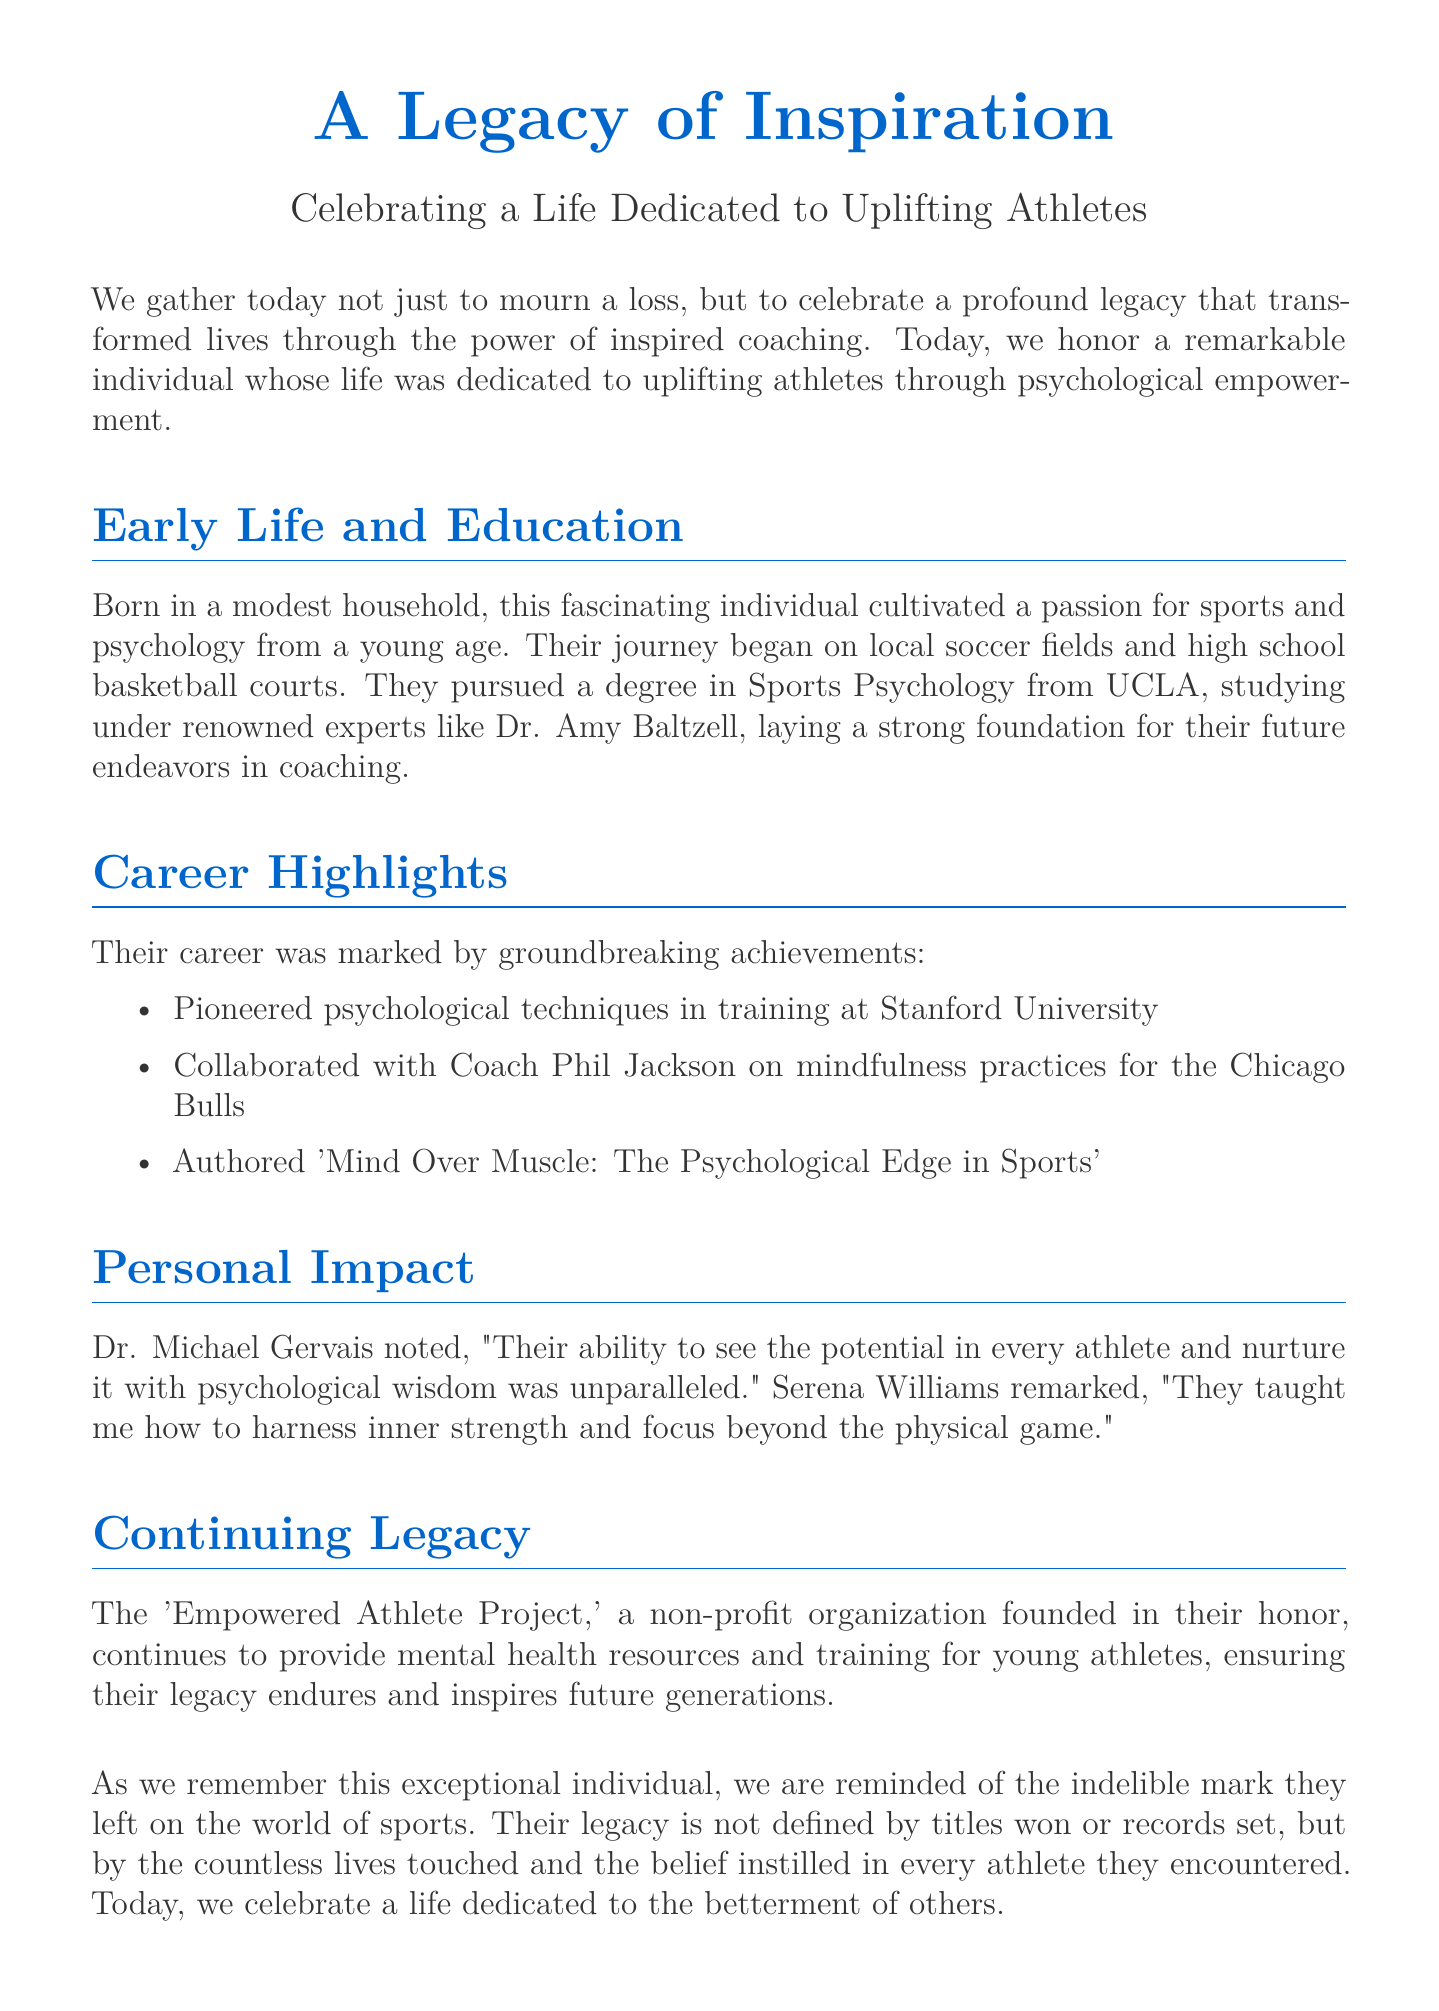What degree did they pursue? The document states they pursued a degree in Sports Psychology from UCLA, which is mentioned under the Early Life and Education section.
Answer: Sports Psychology Which organization did they collaborate with? The document indicates that they collaborated with Coach Phil Jackson, as noted in the Career Highlights section.
Answer: Coach Phil Jackson What is the title of the book they authored? The document lists 'Mind Over Muscle: The Psychological Edge in Sports' as the title they authored, found in the Career Highlights.
Answer: Mind Over Muscle: The Psychological Edge in Sports Who remarked on their ability to see potential in athletes? Dr. Michael Gervais is quoted in the document reflecting on their contributions, found in the Personal Impact section.
Answer: Dr. Michael Gervais What is the name of the non-profit organization founded in their honor? The document mentions 'Empowered Athlete Project' as the non-profit organization set up to continue their legacy, highlighted in the Continuing Legacy section.
Answer: Empowered Athlete Project Which university did they pioneer psychological techniques? The Career Highlights section explicitly states that they pioneered psychological techniques at Stanford University.
Answer: Stanford University What was the primary focus of their coaching philosophy? The eulogy emphasizes their focus on uplifting athletes through psychological empowerment, evident in the introduction.
Answer: Psychological empowerment What aspect of their legacy is emphasized in the eulogy? The document highlights that their legacy is defined by the lives they touched and the belief they instilled in athletes, noted in the Continuing Legacy section.
Answer: Lives touched What was their early life like? The document describes their early life as beginning in a modest household where they cultivated a passion for sports and psychology.
Answer: Modest household 